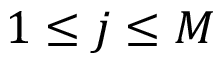Convert formula to latex. <formula><loc_0><loc_0><loc_500><loc_500>1 \leq j \leq M</formula> 